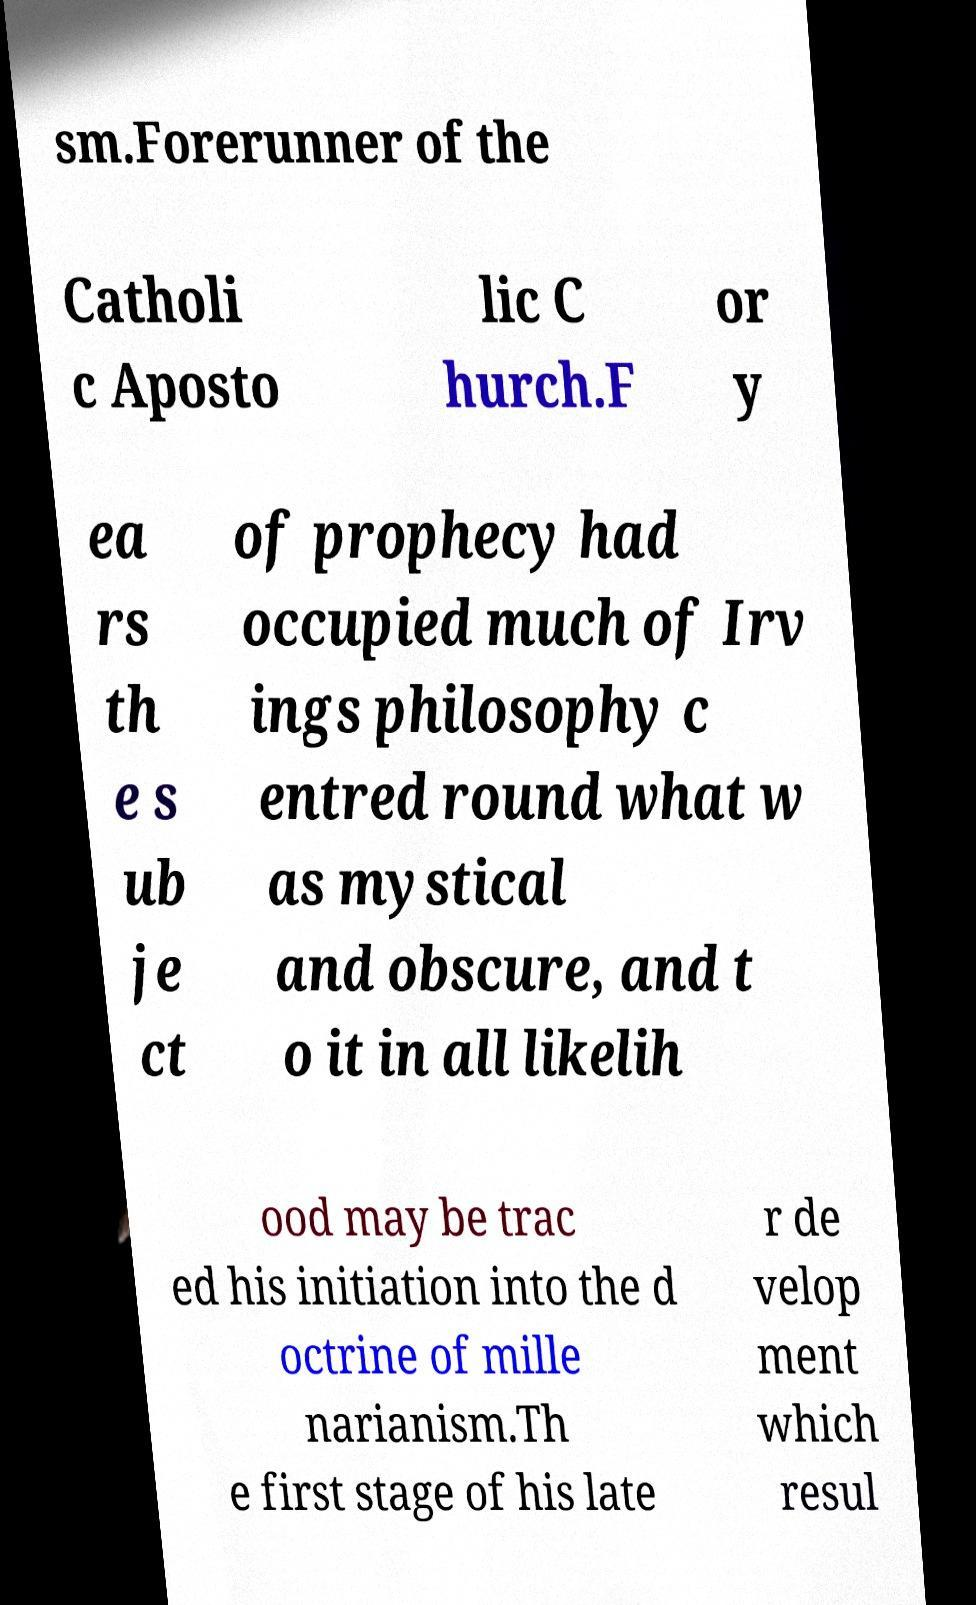I need the written content from this picture converted into text. Can you do that? sm.Forerunner of the Catholi c Aposto lic C hurch.F or y ea rs th e s ub je ct of prophecy had occupied much of Irv ings philosophy c entred round what w as mystical and obscure, and t o it in all likelih ood may be trac ed his initiation into the d octrine of mille narianism.Th e first stage of his late r de velop ment which resul 